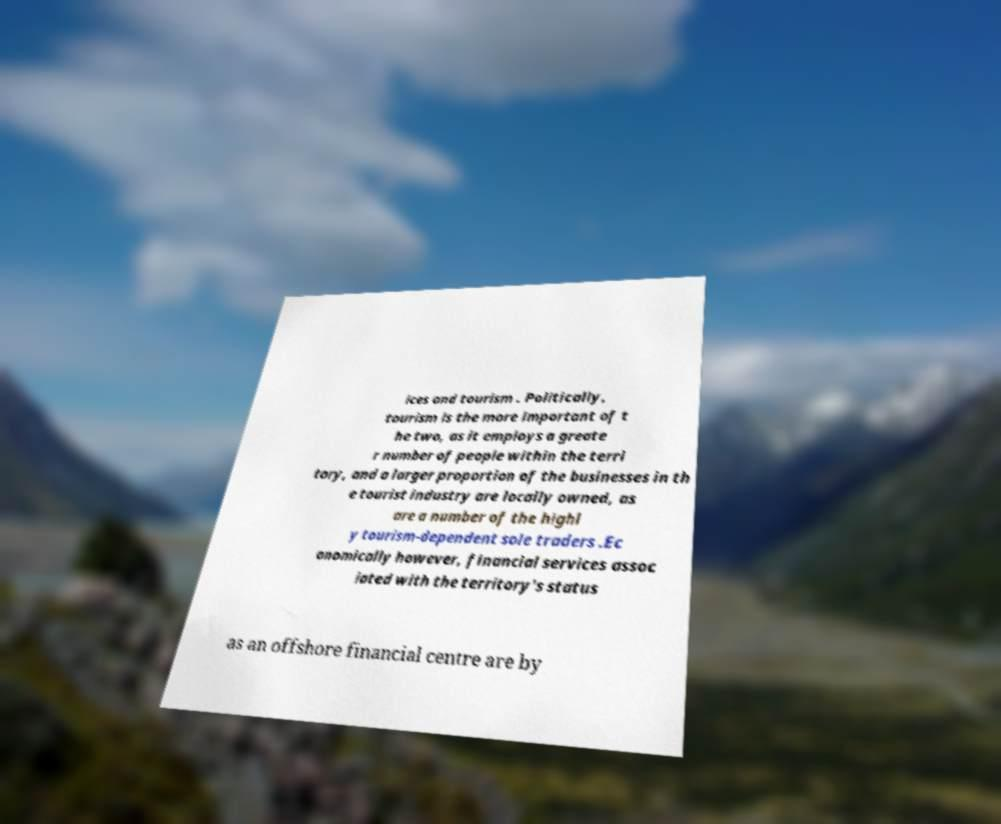Could you extract and type out the text from this image? ices and tourism . Politically, tourism is the more important of t he two, as it employs a greate r number of people within the terri tory, and a larger proportion of the businesses in th e tourist industry are locally owned, as are a number of the highl y tourism-dependent sole traders .Ec onomically however, financial services assoc iated with the territory's status as an offshore financial centre are by 